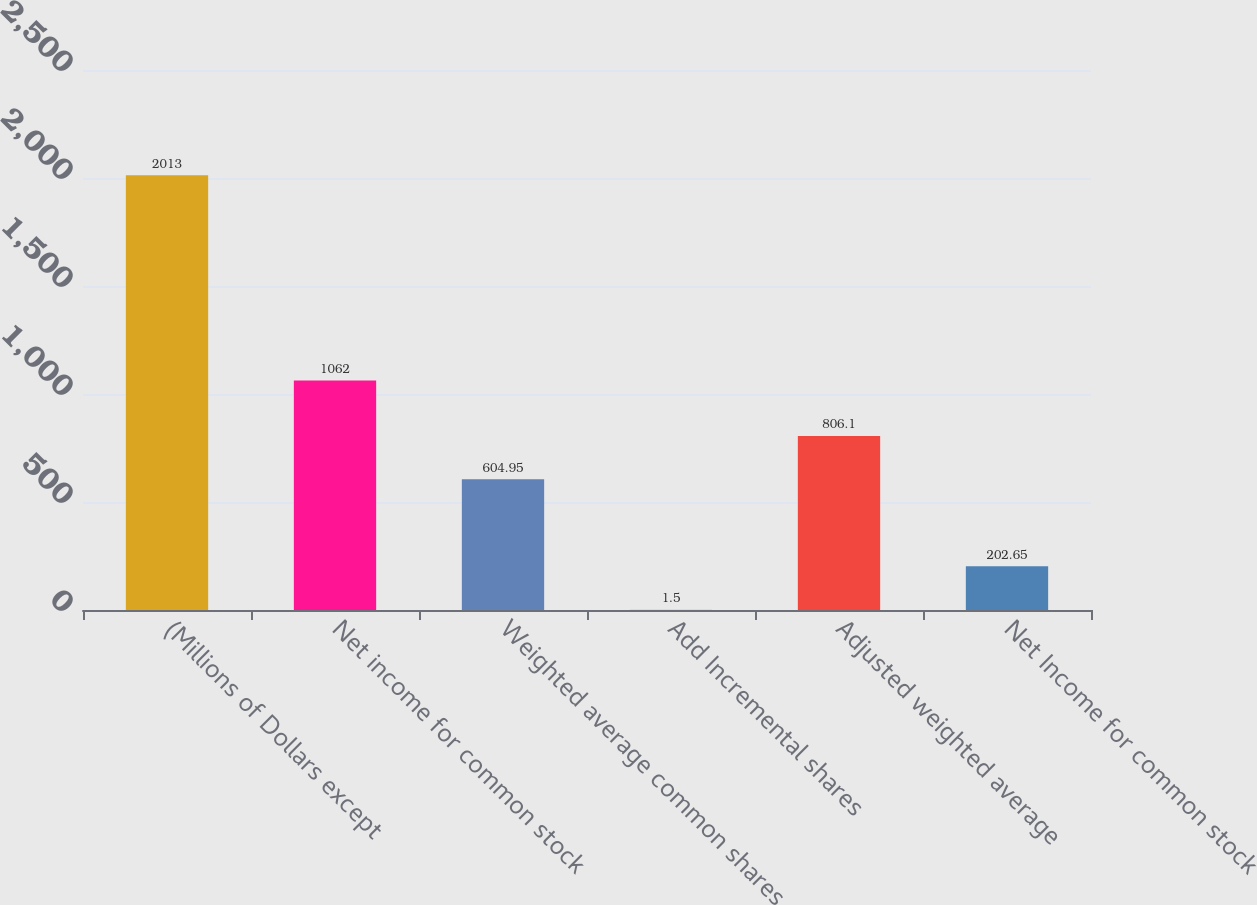<chart> <loc_0><loc_0><loc_500><loc_500><bar_chart><fcel>(Millions of Dollars except<fcel>Net income for common stock<fcel>Weighted average common shares<fcel>Add Incremental shares<fcel>Adjusted weighted average<fcel>Net Income for common stock<nl><fcel>2013<fcel>1062<fcel>604.95<fcel>1.5<fcel>806.1<fcel>202.65<nl></chart> 